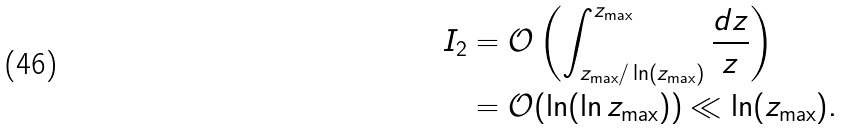Convert formula to latex. <formula><loc_0><loc_0><loc_500><loc_500>I _ { 2 } & = \mathcal { O } \left ( \int _ { z _ { \max } / \ln ( z _ { \max } ) } ^ { z _ { \max } } \frac { d z } { z } \right ) \\ & = \mathcal { O } ( \ln ( \ln z _ { \max } ) ) \ll \ln ( z _ { \max } ) .</formula> 